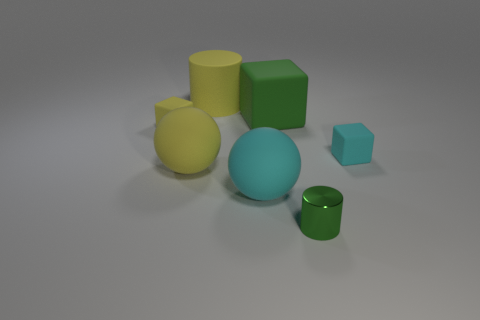Are there fewer small cyan rubber cubes behind the small yellow block than small green cylinders?
Your answer should be compact. Yes. There is a big yellow ball; how many small cyan rubber things are on the right side of it?
Your response must be concise. 1. There is a cyan thing on the left side of the green thing in front of the yellow sphere that is in front of the green matte object; what is its size?
Make the answer very short. Large. Do the shiny thing and the small rubber thing right of the large cyan sphere have the same shape?
Offer a terse response. No. The cyan block that is made of the same material as the big green cube is what size?
Your response must be concise. Small. Is there anything else that has the same color as the big rubber cylinder?
Ensure brevity in your answer.  Yes. The cyan object that is on the right side of the green object in front of the tiny cube on the left side of the green cylinder is made of what material?
Your answer should be compact. Rubber. How many metallic objects are green cylinders or yellow things?
Your response must be concise. 1. Is the large cylinder the same color as the metal object?
Provide a short and direct response. No. Are there any other things that are made of the same material as the big yellow cylinder?
Make the answer very short. Yes. 